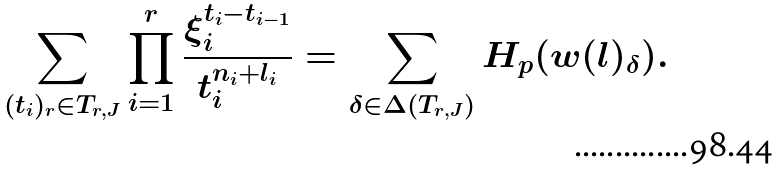Convert formula to latex. <formula><loc_0><loc_0><loc_500><loc_500>\sum _ { ( t _ { i } ) _ { r } \in T _ { r , J } } \prod _ { i = 1 } ^ { r } \frac { \xi _ { i } ^ { t _ { i } - t _ { i - 1 } } } { t _ { i } ^ { n _ { i } + l _ { i } } } = \sum _ { \delta \in \Delta ( T _ { r , J } ) } H _ { p } ( { w } ( { l } ) _ { \delta } ) .</formula> 